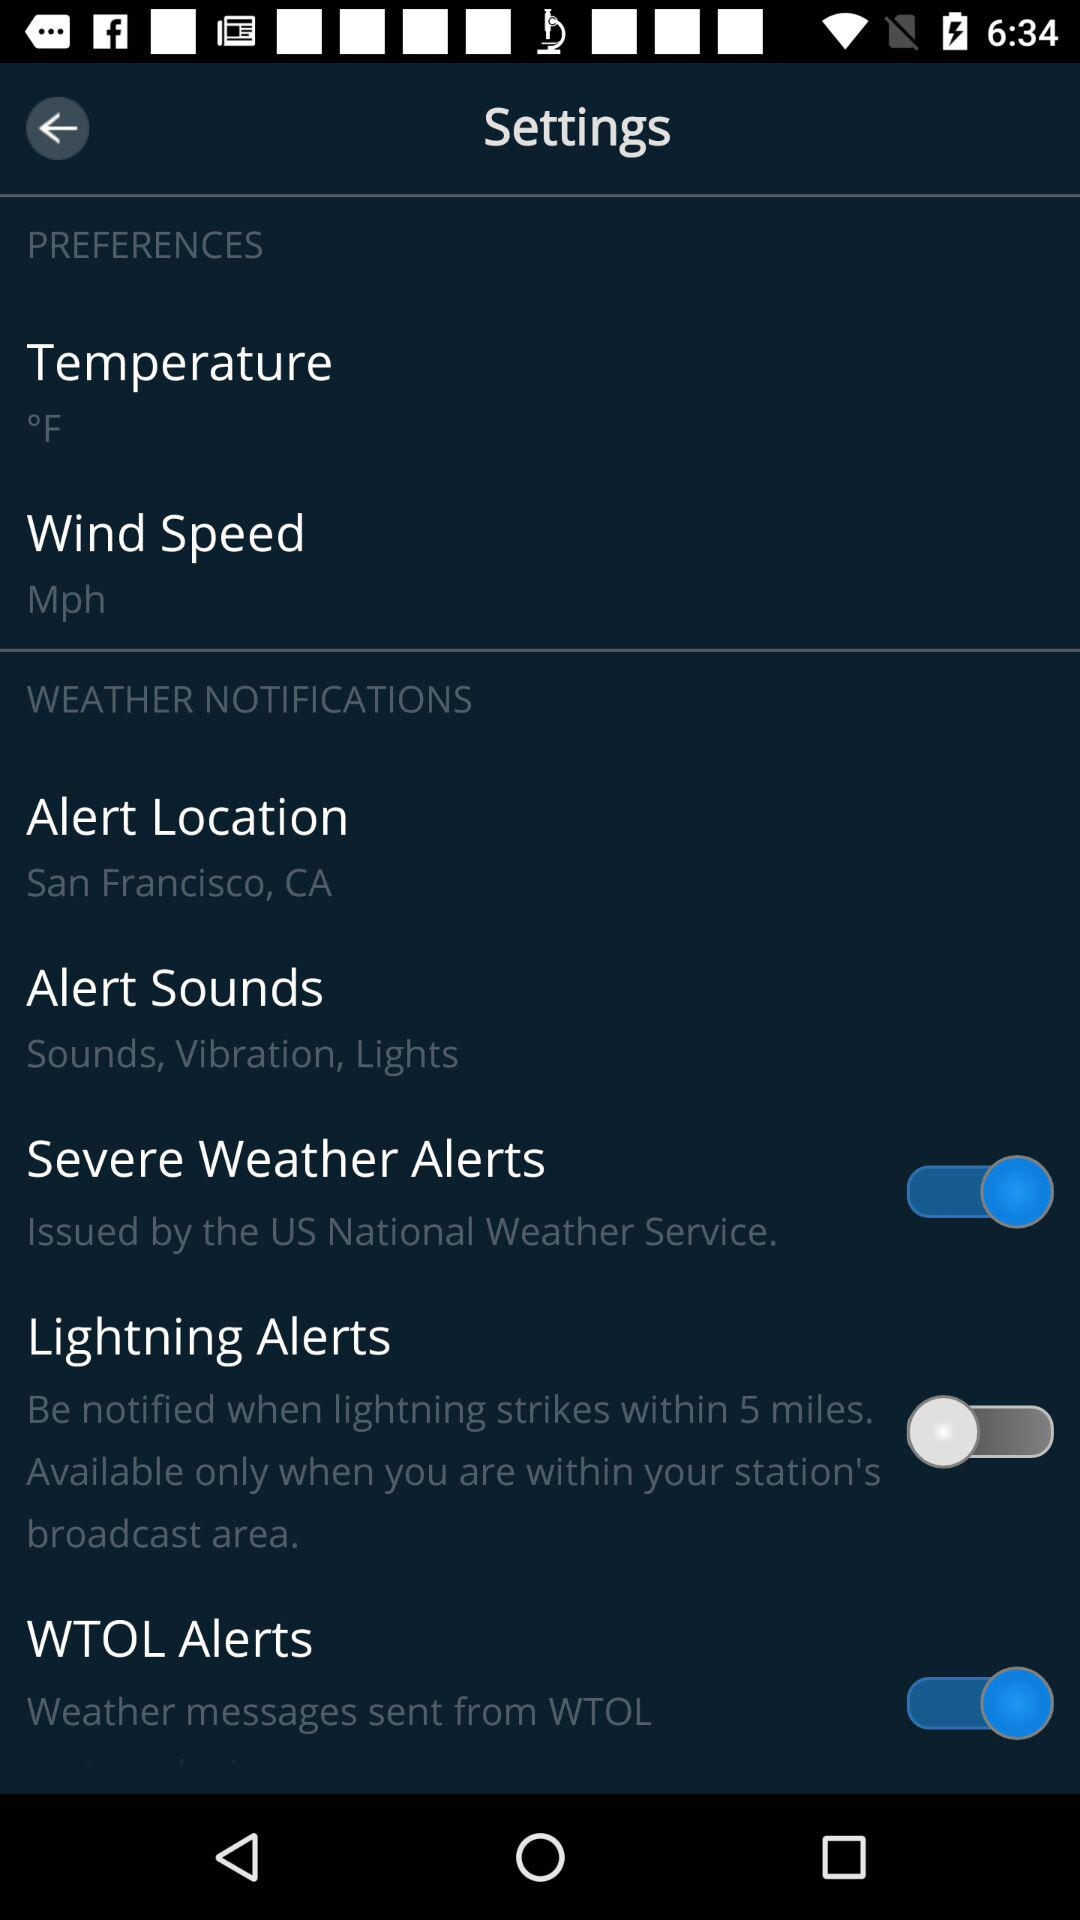What is the alert location? The alert location is San Francisco, CA. 